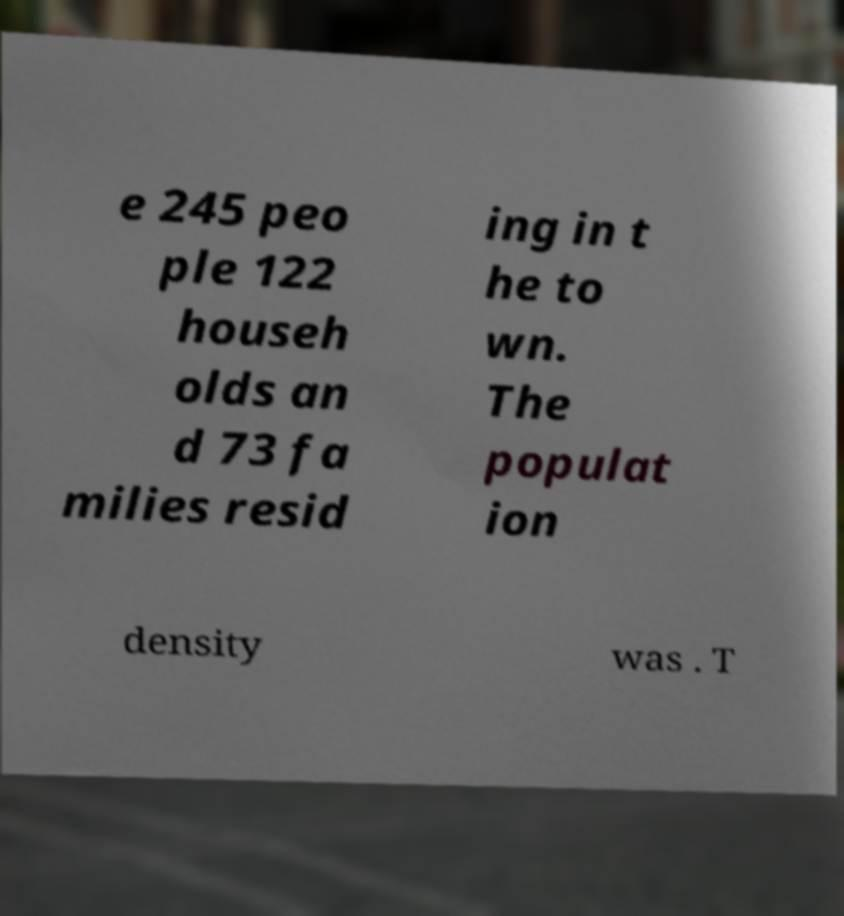What messages or text are displayed in this image? I need them in a readable, typed format. e 245 peo ple 122 househ olds an d 73 fa milies resid ing in t he to wn. The populat ion density was . T 